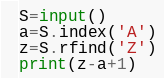Convert code to text. <code><loc_0><loc_0><loc_500><loc_500><_Python_>S=input()
a=S.index('A')
z=S.rfind('Z')
print(z-a+1)
</code> 